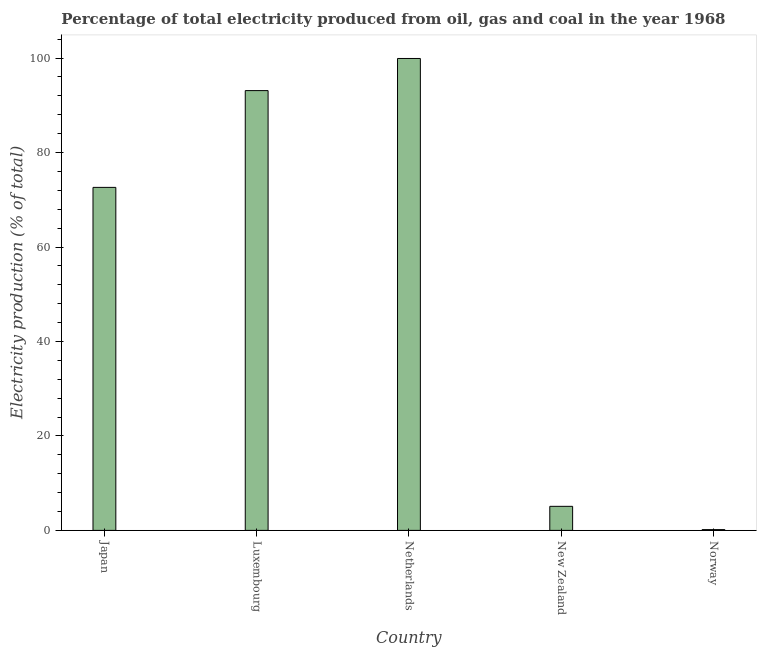Does the graph contain grids?
Your response must be concise. No. What is the title of the graph?
Make the answer very short. Percentage of total electricity produced from oil, gas and coal in the year 1968. What is the label or title of the Y-axis?
Make the answer very short. Electricity production (% of total). What is the electricity production in Luxembourg?
Offer a very short reply. 93.11. Across all countries, what is the maximum electricity production?
Your response must be concise. 99.92. Across all countries, what is the minimum electricity production?
Your answer should be very brief. 0.16. What is the sum of the electricity production?
Keep it short and to the point. 270.91. What is the difference between the electricity production in Japan and Luxembourg?
Keep it short and to the point. -20.49. What is the average electricity production per country?
Keep it short and to the point. 54.18. What is the median electricity production?
Keep it short and to the point. 72.62. What is the ratio of the electricity production in Japan to that in New Zealand?
Keep it short and to the point. 14.26. Is the electricity production in Netherlands less than that in New Zealand?
Give a very brief answer. No. Is the difference between the electricity production in New Zealand and Norway greater than the difference between any two countries?
Your answer should be compact. No. What is the difference between the highest and the second highest electricity production?
Provide a succinct answer. 6.8. What is the difference between the highest and the lowest electricity production?
Your answer should be very brief. 99.75. In how many countries, is the electricity production greater than the average electricity production taken over all countries?
Your answer should be very brief. 3. How many bars are there?
Keep it short and to the point. 5. Are all the bars in the graph horizontal?
Provide a succinct answer. No. What is the Electricity production (% of total) of Japan?
Provide a short and direct response. 72.62. What is the Electricity production (% of total) of Luxembourg?
Offer a very short reply. 93.11. What is the Electricity production (% of total) of Netherlands?
Offer a very short reply. 99.92. What is the Electricity production (% of total) in New Zealand?
Your response must be concise. 5.09. What is the Electricity production (% of total) in Norway?
Ensure brevity in your answer.  0.16. What is the difference between the Electricity production (% of total) in Japan and Luxembourg?
Your answer should be very brief. -20.49. What is the difference between the Electricity production (% of total) in Japan and Netherlands?
Keep it short and to the point. -27.29. What is the difference between the Electricity production (% of total) in Japan and New Zealand?
Offer a terse response. 67.53. What is the difference between the Electricity production (% of total) in Japan and Norway?
Ensure brevity in your answer.  72.46. What is the difference between the Electricity production (% of total) in Luxembourg and Netherlands?
Offer a very short reply. -6.8. What is the difference between the Electricity production (% of total) in Luxembourg and New Zealand?
Your response must be concise. 88.02. What is the difference between the Electricity production (% of total) in Luxembourg and Norway?
Make the answer very short. 92.95. What is the difference between the Electricity production (% of total) in Netherlands and New Zealand?
Provide a succinct answer. 94.82. What is the difference between the Electricity production (% of total) in Netherlands and Norway?
Offer a terse response. 99.75. What is the difference between the Electricity production (% of total) in New Zealand and Norway?
Keep it short and to the point. 4.93. What is the ratio of the Electricity production (% of total) in Japan to that in Luxembourg?
Your answer should be compact. 0.78. What is the ratio of the Electricity production (% of total) in Japan to that in Netherlands?
Your answer should be very brief. 0.73. What is the ratio of the Electricity production (% of total) in Japan to that in New Zealand?
Make the answer very short. 14.26. What is the ratio of the Electricity production (% of total) in Japan to that in Norway?
Provide a succinct answer. 446.88. What is the ratio of the Electricity production (% of total) in Luxembourg to that in Netherlands?
Keep it short and to the point. 0.93. What is the ratio of the Electricity production (% of total) in Luxembourg to that in New Zealand?
Provide a short and direct response. 18.28. What is the ratio of the Electricity production (% of total) in Luxembourg to that in Norway?
Your response must be concise. 572.96. What is the ratio of the Electricity production (% of total) in Netherlands to that in New Zealand?
Provide a succinct answer. 19.62. What is the ratio of the Electricity production (% of total) in Netherlands to that in Norway?
Provide a short and direct response. 614.82. What is the ratio of the Electricity production (% of total) in New Zealand to that in Norway?
Give a very brief answer. 31.34. 